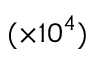<formula> <loc_0><loc_0><loc_500><loc_500>( \times 1 0 ^ { 4 } )</formula> 